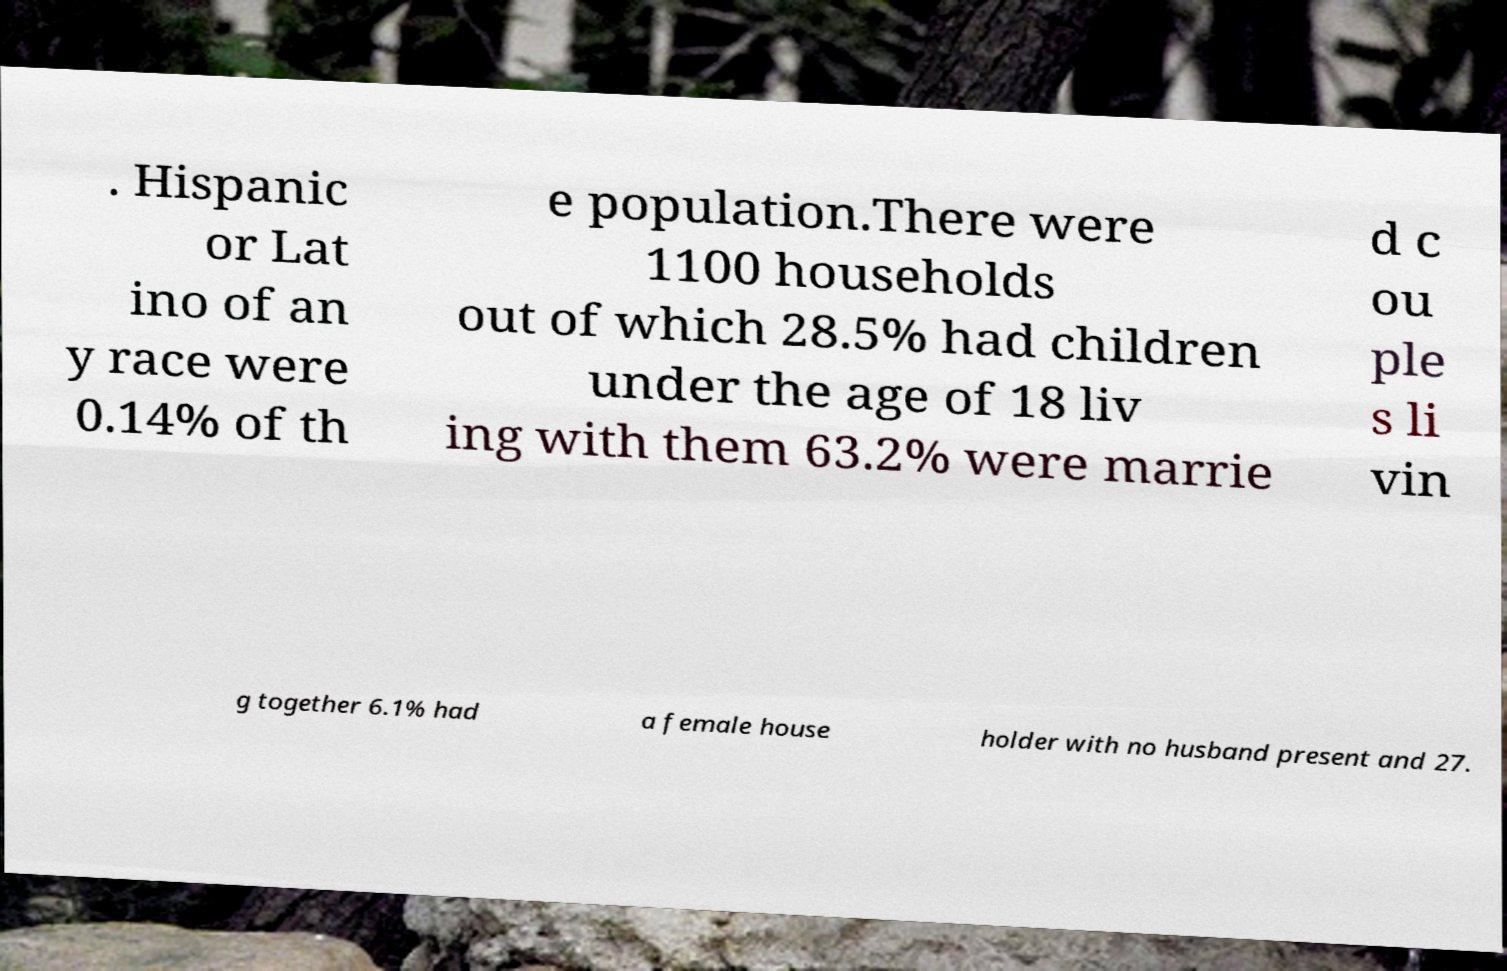There's text embedded in this image that I need extracted. Can you transcribe it verbatim? . Hispanic or Lat ino of an y race were 0.14% of th e population.There were 1100 households out of which 28.5% had children under the age of 18 liv ing with them 63.2% were marrie d c ou ple s li vin g together 6.1% had a female house holder with no husband present and 27. 